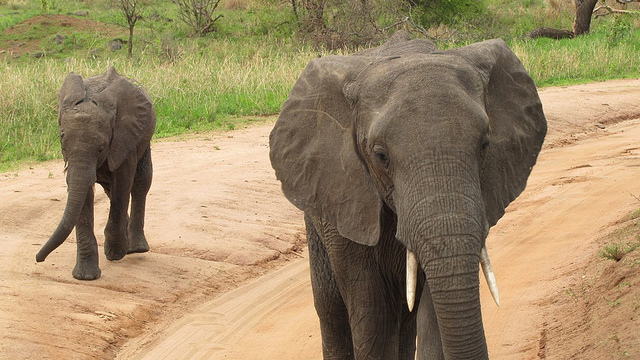<image>Are they old? I don't know if they are old. It is uncertain. Are they old? They are not old. 